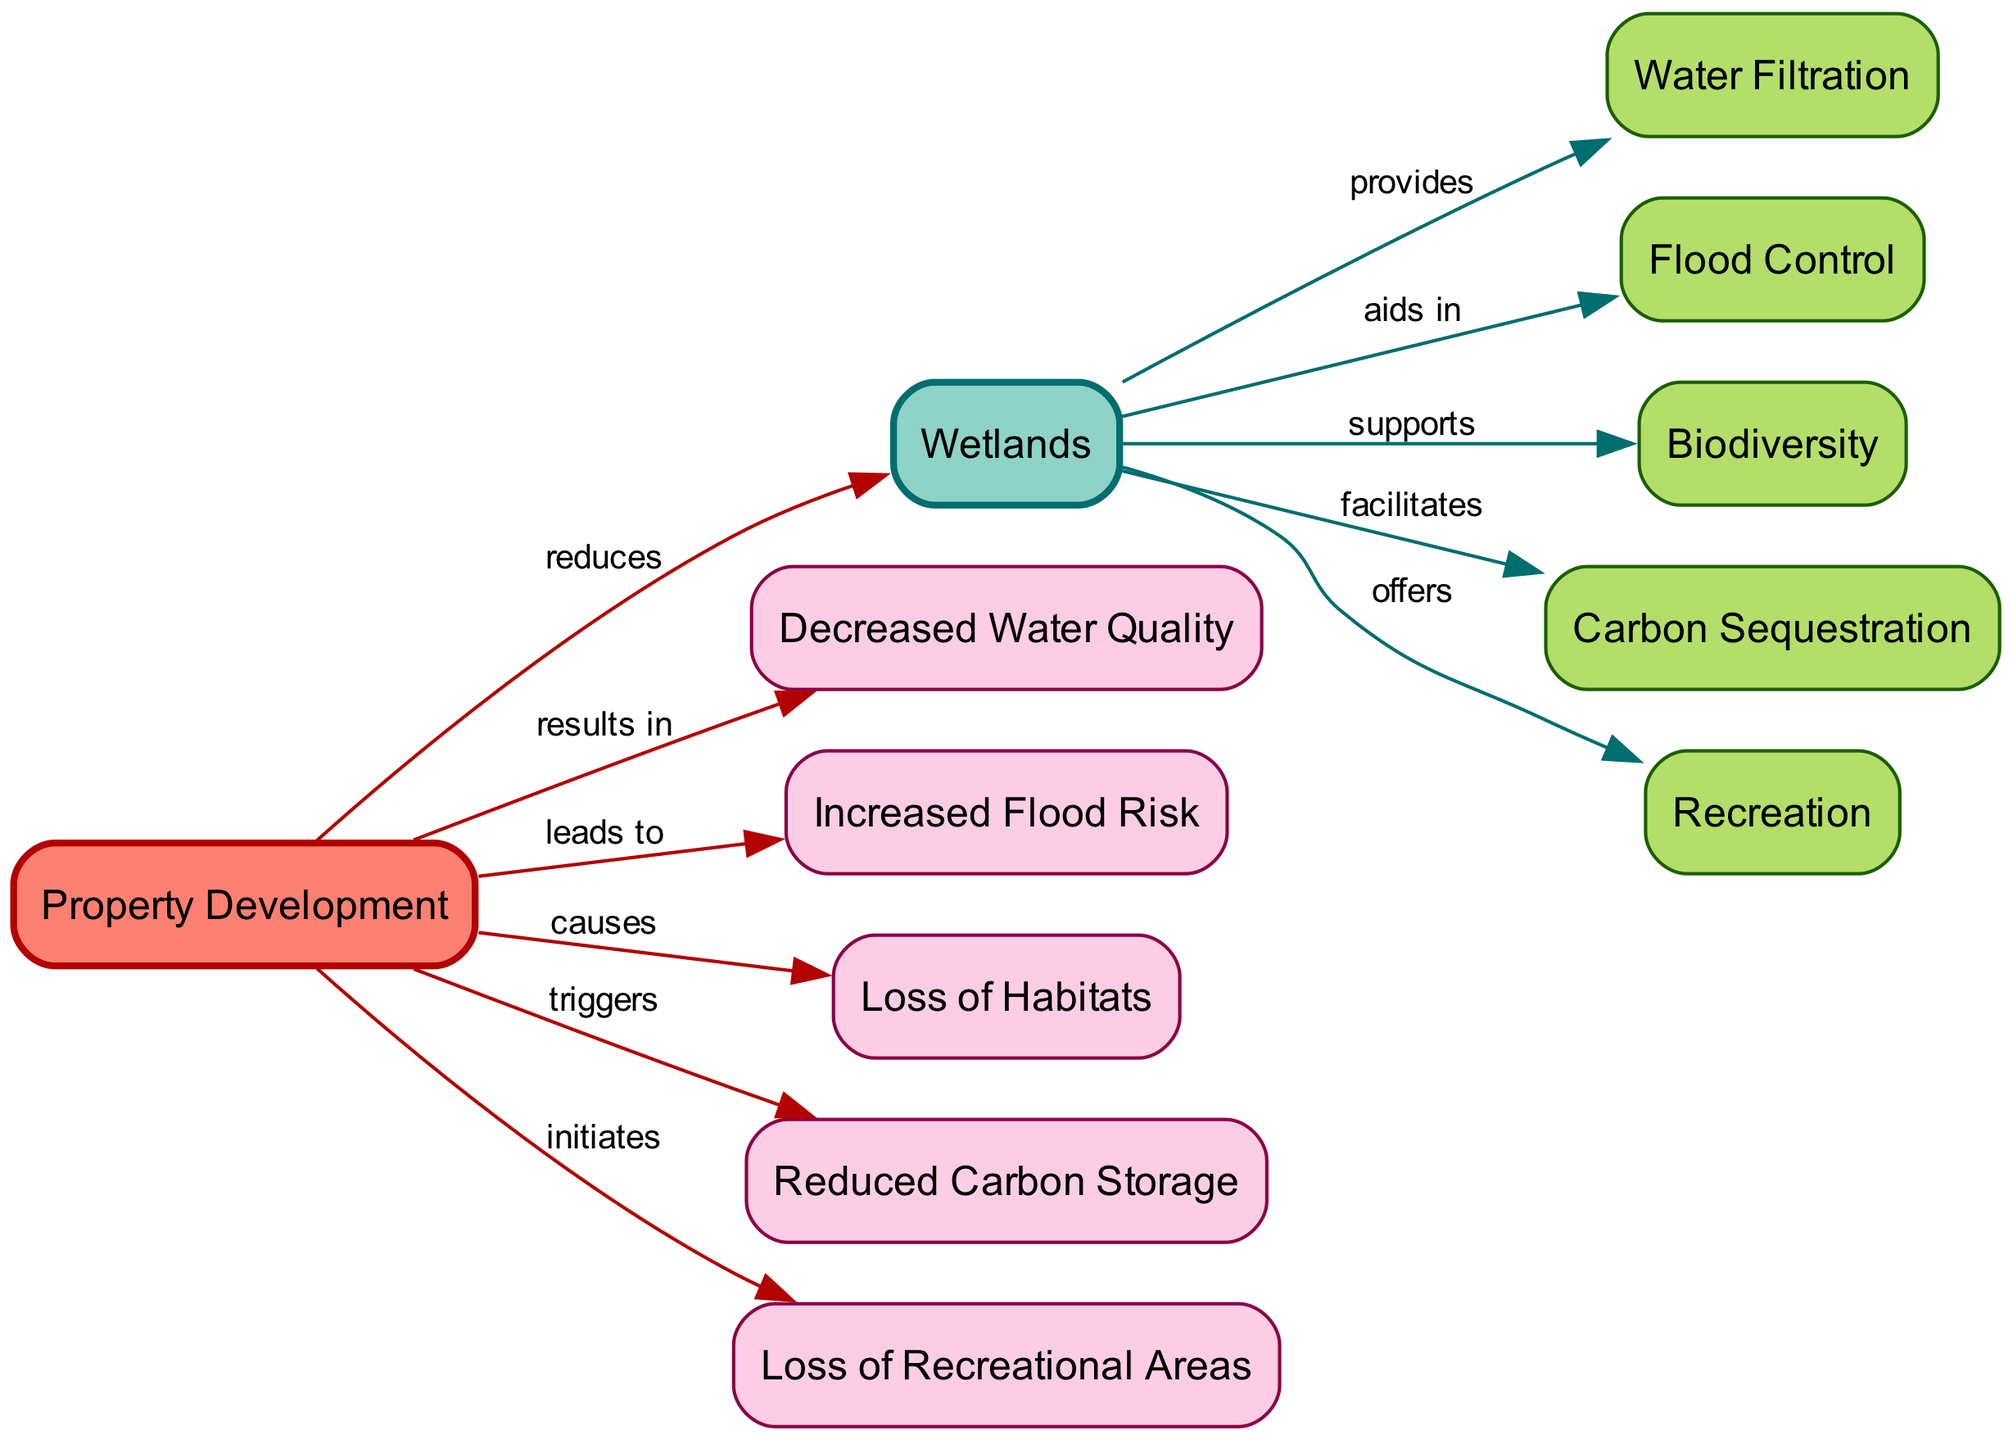What is the central node in the diagram? The central node, which connects various ecosystem services and property development, is "Wetlands." It acts as the main source of multiple benefits.
Answer: Wetlands How many nodes are in the diagram? By counting the distinct entities listed, we find that there are a total of 12 nodes present in the diagram which include both ecosystem services and development aspects.
Answer: 12 What does "Wetlands" provide according to the diagram? The diagram indicates that "Wetlands" provides "Water Filtration" and this relationship is shown by a direct edge connected to it.
Answer: Water Filtration What effect does "Property Development" have on "Flood Control"? The relationship shows that "Property Development" leads to an "Increased Flood Risk," indicating that construction activities negatively affect the flood control benefits provided by wetlands.
Answer: Increased Flood Risk Which services are reduced due to "Property Development"? By evaluating the edges linked to "Property Development," we see it reduces water quality, increases flood risk, causes loss of habitats, reduces carbon storage, and initiates loss of recreational areas, highlighting the negative consequences of development.
Answer: Decreased Water Quality, Increased Flood Risk, Loss of Habitats, Reduced Carbon Storage, Loss of Recreational Areas What is the relationship between "Wetlands" and "Biodiversity"? The diagram shows that "Wetlands" supports "Biodiversity," establishing a beneficial connection that emphasizes the ecological importance of wetlands in maintaining species diversity.
Answer: supports What is the role of "Carbon Sequestration" in this ecosystem? "Carbon Sequestration" is facilitated by "Wetlands," meaning wetlands play a significant role in storing carbon and mitigating climate change effects.
Answer: facilitates What category does "Property Development" fall under in the diagram? "Property Development" is represented as a node that primarily causes negative outcomes related to the ecosystem services provided by wetlands, indicating an adverse activity on the environment.
Answer: negative impact Which ecosystem service is linked to recreation according to the diagram? The diagram states that "Wetlands" offers "Recreation," connecting both the ecological role of wetlands with the recreational opportunities they create for people.
Answer: Recreation 